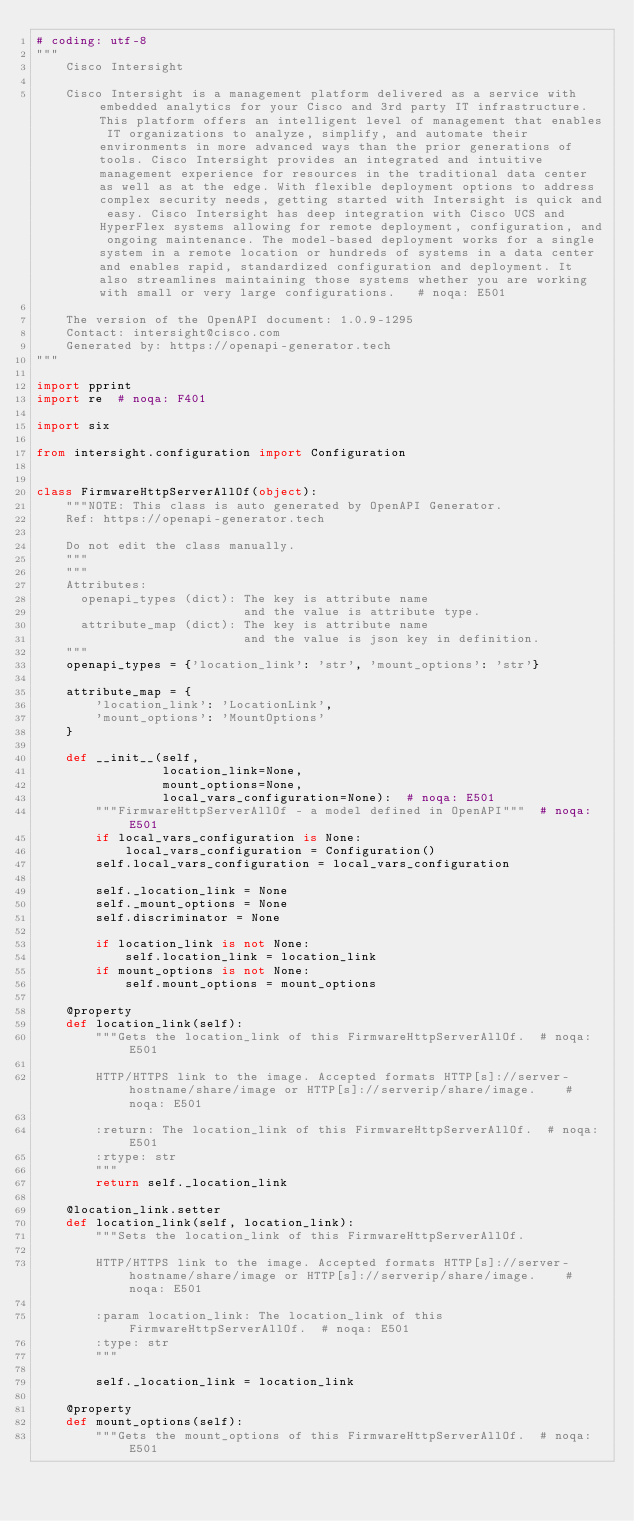<code> <loc_0><loc_0><loc_500><loc_500><_Python_># coding: utf-8
"""
    Cisco Intersight

    Cisco Intersight is a management platform delivered as a service with embedded analytics for your Cisco and 3rd party IT infrastructure. This platform offers an intelligent level of management that enables IT organizations to analyze, simplify, and automate their environments in more advanced ways than the prior generations of tools. Cisco Intersight provides an integrated and intuitive management experience for resources in the traditional data center as well as at the edge. With flexible deployment options to address complex security needs, getting started with Intersight is quick and easy. Cisco Intersight has deep integration with Cisco UCS and HyperFlex systems allowing for remote deployment, configuration, and ongoing maintenance. The model-based deployment works for a single system in a remote location or hundreds of systems in a data center and enables rapid, standardized configuration and deployment. It also streamlines maintaining those systems whether you are working with small or very large configurations.   # noqa: E501

    The version of the OpenAPI document: 1.0.9-1295
    Contact: intersight@cisco.com
    Generated by: https://openapi-generator.tech
"""

import pprint
import re  # noqa: F401

import six

from intersight.configuration import Configuration


class FirmwareHttpServerAllOf(object):
    """NOTE: This class is auto generated by OpenAPI Generator.
    Ref: https://openapi-generator.tech

    Do not edit the class manually.
    """
    """
    Attributes:
      openapi_types (dict): The key is attribute name
                            and the value is attribute type.
      attribute_map (dict): The key is attribute name
                            and the value is json key in definition.
    """
    openapi_types = {'location_link': 'str', 'mount_options': 'str'}

    attribute_map = {
        'location_link': 'LocationLink',
        'mount_options': 'MountOptions'
    }

    def __init__(self,
                 location_link=None,
                 mount_options=None,
                 local_vars_configuration=None):  # noqa: E501
        """FirmwareHttpServerAllOf - a model defined in OpenAPI"""  # noqa: E501
        if local_vars_configuration is None:
            local_vars_configuration = Configuration()
        self.local_vars_configuration = local_vars_configuration

        self._location_link = None
        self._mount_options = None
        self.discriminator = None

        if location_link is not None:
            self.location_link = location_link
        if mount_options is not None:
            self.mount_options = mount_options

    @property
    def location_link(self):
        """Gets the location_link of this FirmwareHttpServerAllOf.  # noqa: E501

        HTTP/HTTPS link to the image. Accepted formats HTTP[s]://server-hostname/share/image or HTTP[s]://serverip/share/image.    # noqa: E501

        :return: The location_link of this FirmwareHttpServerAllOf.  # noqa: E501
        :rtype: str
        """
        return self._location_link

    @location_link.setter
    def location_link(self, location_link):
        """Sets the location_link of this FirmwareHttpServerAllOf.

        HTTP/HTTPS link to the image. Accepted formats HTTP[s]://server-hostname/share/image or HTTP[s]://serverip/share/image.    # noqa: E501

        :param location_link: The location_link of this FirmwareHttpServerAllOf.  # noqa: E501
        :type: str
        """

        self._location_link = location_link

    @property
    def mount_options(self):
        """Gets the mount_options of this FirmwareHttpServerAllOf.  # noqa: E501
</code> 